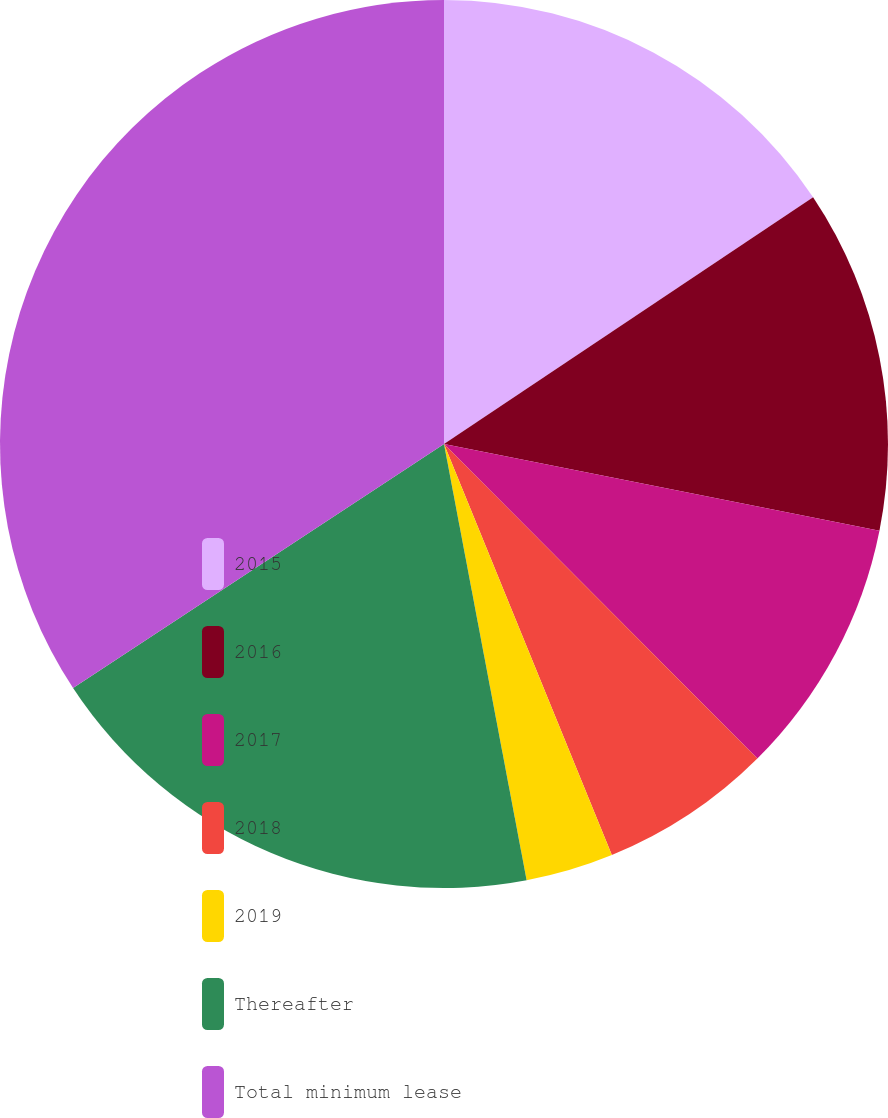Convert chart. <chart><loc_0><loc_0><loc_500><loc_500><pie_chart><fcel>2015<fcel>2016<fcel>2017<fcel>2018<fcel>2019<fcel>Thereafter<fcel>Total minimum lease<nl><fcel>15.62%<fcel>12.51%<fcel>9.4%<fcel>6.3%<fcel>3.19%<fcel>18.72%<fcel>34.26%<nl></chart> 